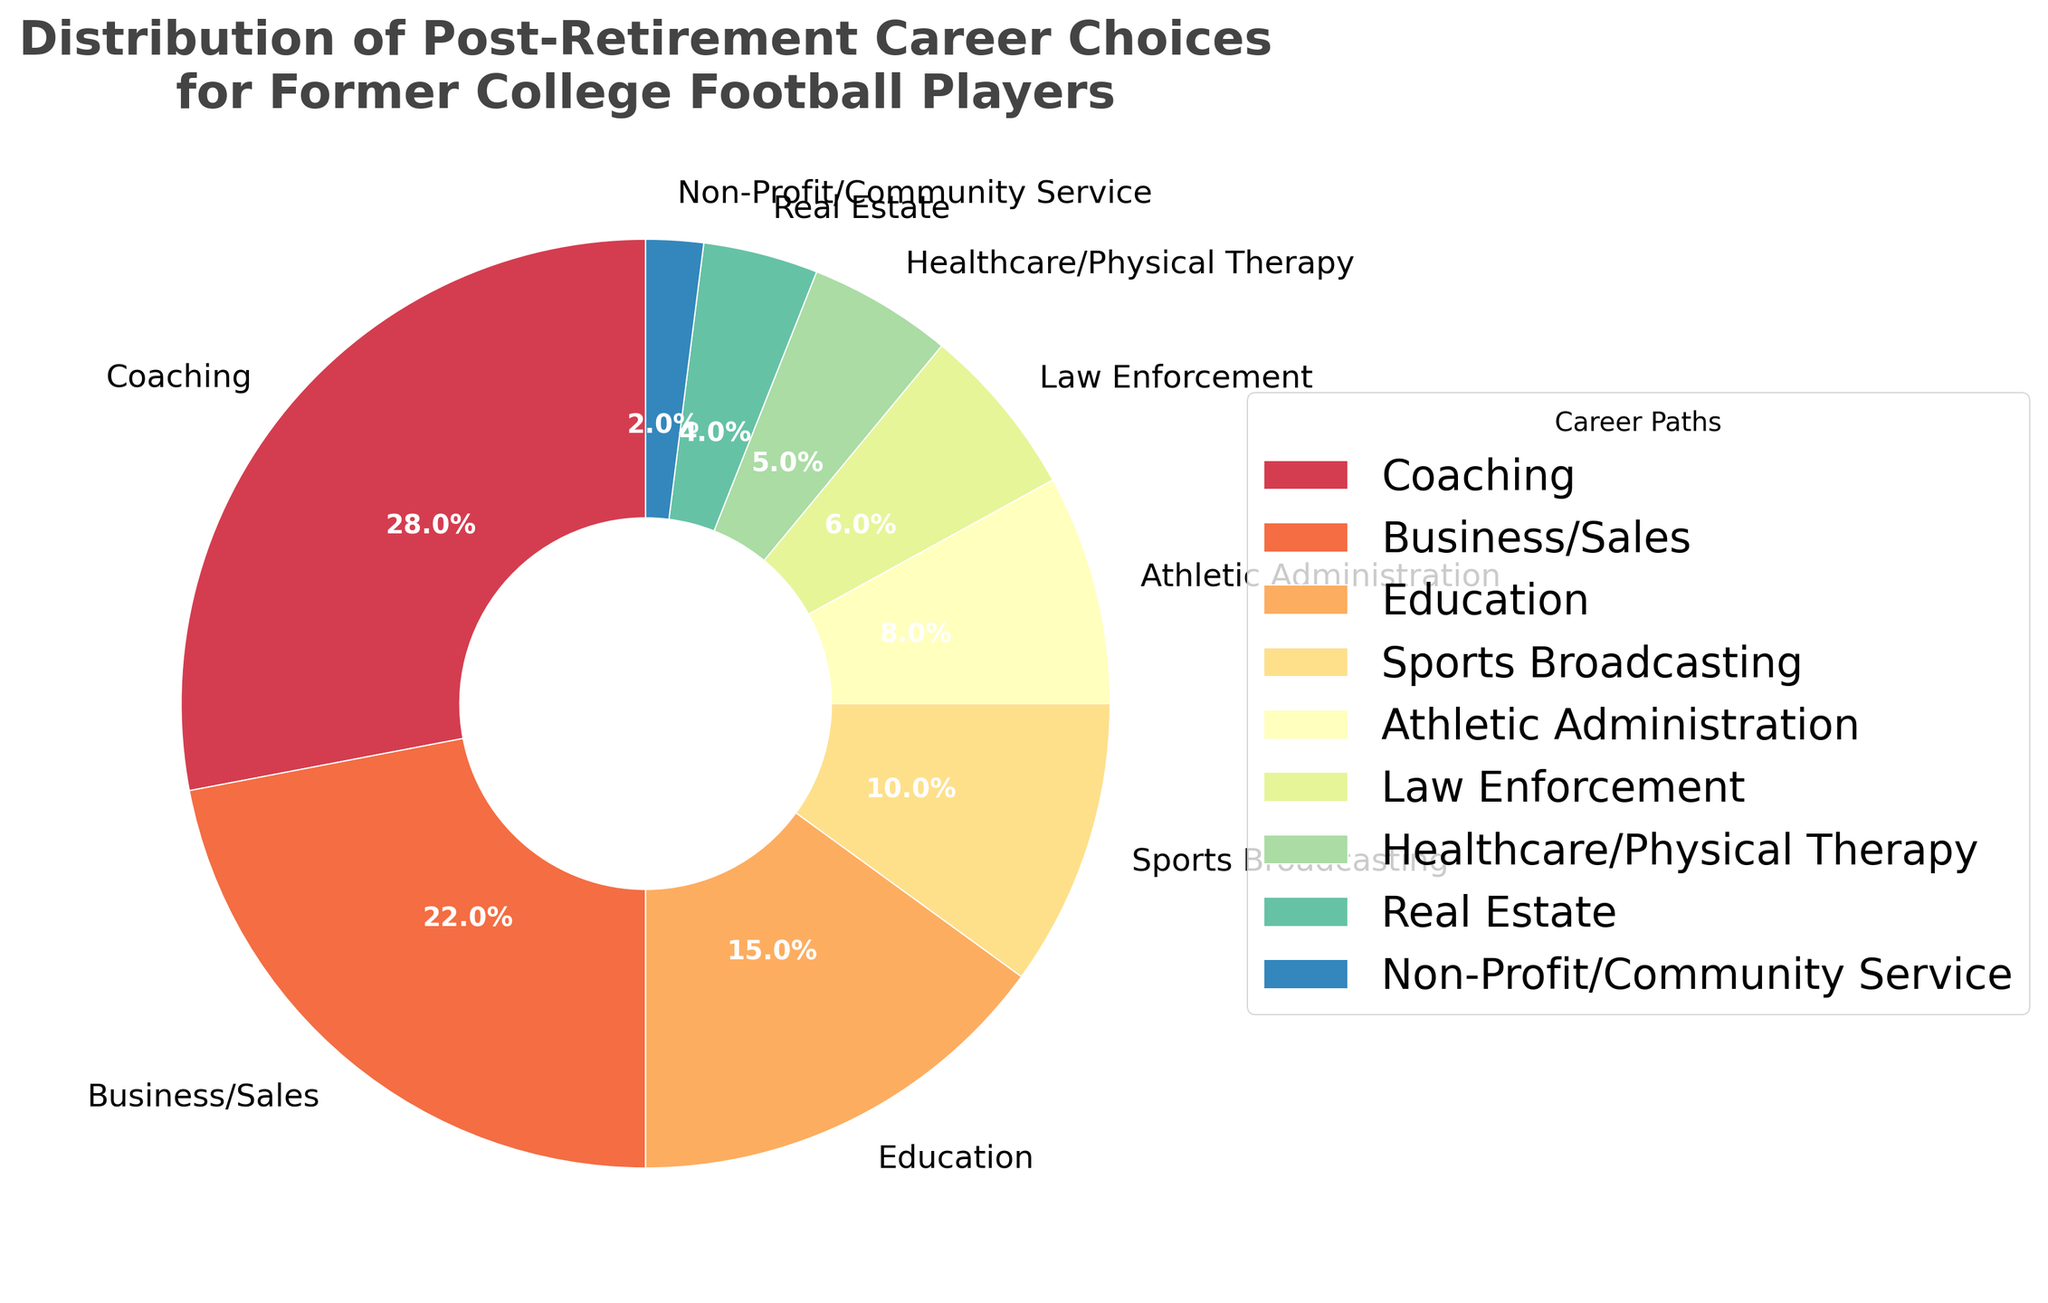Which career path has the highest percentage? The largest slice of the pie chart corresponds to the "Coaching" career path, and the percentage label shows 28%.
Answer: Coaching Which career path has the smallest percentage? The smallest slice of the pie chart represents "Non-Profit/Community Service" with a percentage label showing 2%.
Answer: Non-Profit/Community Service How much more prevalent is Coaching compared to Education? The "Coaching" slice is 28% and the "Education" slice is 15%. The difference is 28% - 15% = 13%.
Answer: 13% What is the combined percentage of all career paths related to sports (Coaching, Sports Broadcasting, Athletic Administration)? Sum the percentages for "Coaching" (28%), "Sports Broadcasting" (10%), and "Athletic Administration" (8%). The total is 28% + 10% + 8% = 46%.
Answer: 46% Which career path occupies more of the pie chart, Law Enforcement or Healthcare/Physical Therapy? Comparing the slices, "Law Enforcement" is 6% and "Healthcare/Physical Therapy" is 5%. Since 6% is greater than 5%, Law Enforcement occupies more.
Answer: Law Enforcement What percentage of former college football players chose Real Estate or Non-Profit/Community Service? Sum the percentages for "Real Estate" (4%) and "Non-Profit/Community Service" (2%). The total is 4% + 2% = 6%.
Answer: 6% Are there more former players in Business/Sales or in Education and Real Estate combined? "Business/Sales" is 22%, and the combined percentage of "Education" (15%) and "Real Estate" (4%) is 15% + 4% = 19%. Since 22% is greater than 19%, there are more in Business/Sales.
Answer: Business/Sales Which segment has the second highest percentage? The second largest slice of the pie chart corresponds to the "Business/Sales" career path, and the percentage label shows 22%.
Answer: Business/Sales 